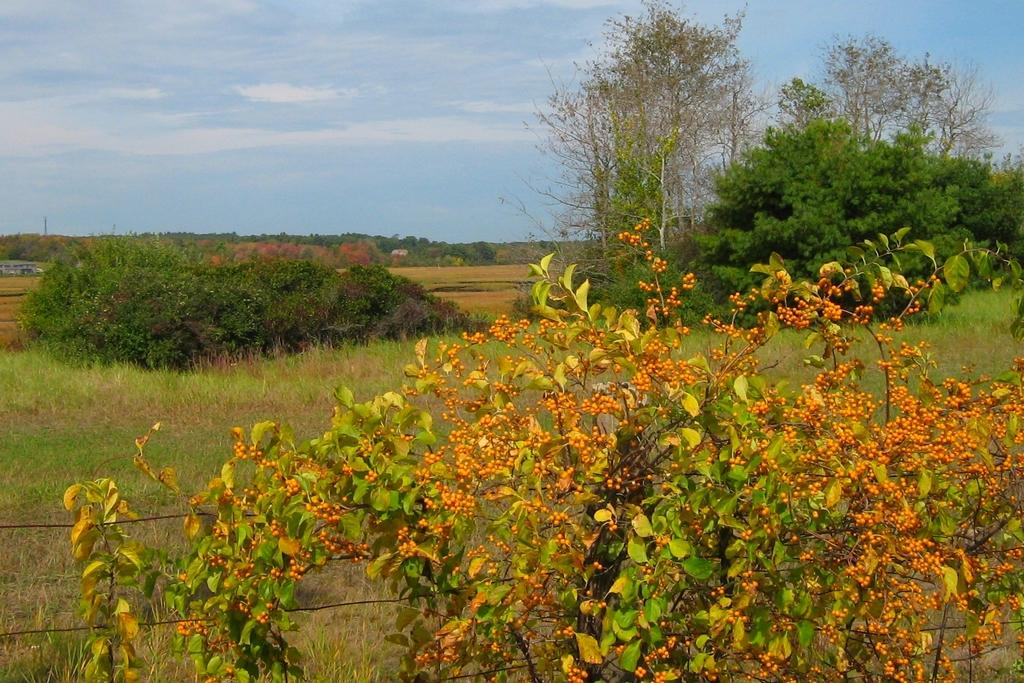What type of vegetation can be seen in the image? There are plants in the image. What type of ground cover is visible in the image? There is grass visible in the image. What can be seen in the sky in the background of the image? There are clouds in the sky in the background of the image. How many bricks are stacked on top of the rod in the image? There are no bricks or rods present in the image. What type of bears can be seen interacting with the plants in the image? There are no bears present in the image; it features plants and grass. 